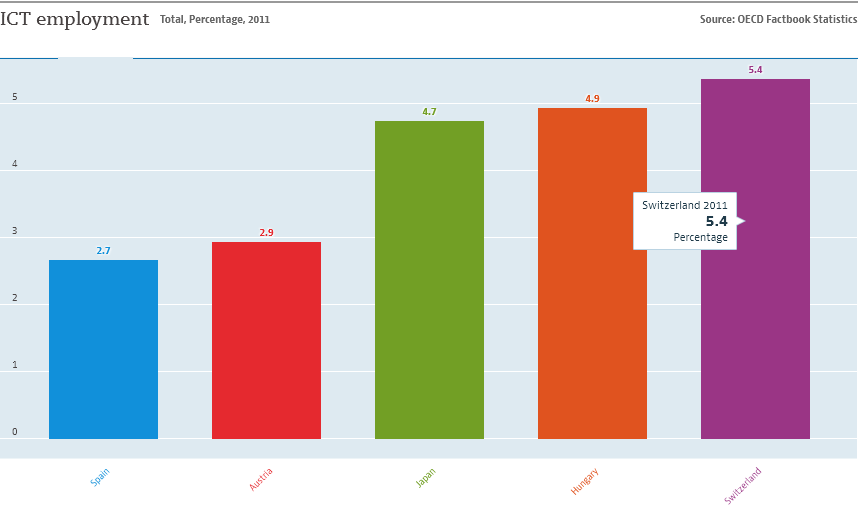Specify some key components in this picture. The distribution of ICT employment between Hungary and Spain is as follows: 7.6% of employment in Hungary and 6.5% of employment in Spain are in the ICT sector. The IT and Communications Technology (ICT) employment size in Hungary is 4.9%. 